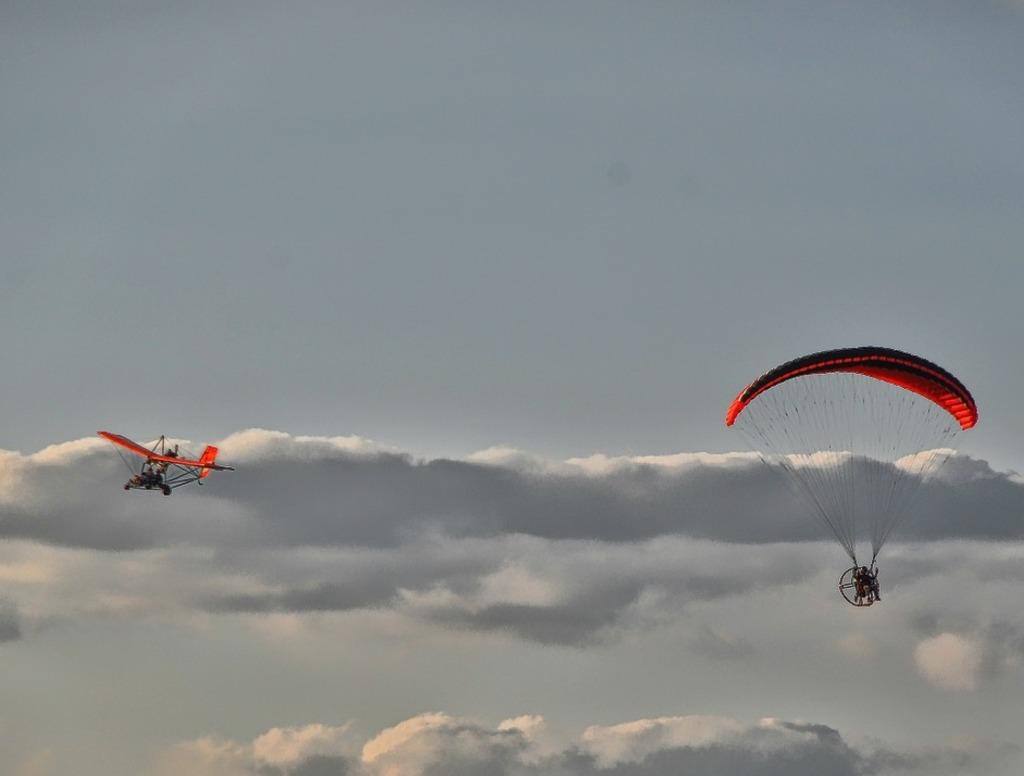What is located on the right side of the image in the foreground? There is a parachute in the foreground of the image, on the right side. What is located on the left side of the image in the foreground? There is an airplane in the foreground of the image, on the left side. What can be seen in the background of the image? The sky is visible in the background of the image. Can you describe the sky in the image? There is at least one cloud in the sky. What type of leather is being used to make the secretary's chair in the image? There is no secretary or chair present in the image; it features a parachute and an airplane. How many wings are visible on the secretary in the image? There is no secretary present in the image, so it is not possible to determine the number of wings. 